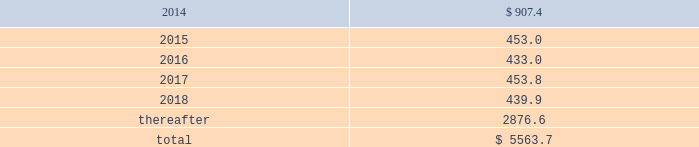Maturities of long-term debt in each of the next five years and beyond are as follows: .
On 4 february 2013 , we issued a $ 400.0 senior fixed-rate 2.75% ( 2.75 % ) note that matures on 3 february 2023 .
Additionally , on 7 august 2013 , we issued a 2.0% ( 2.0 % ) eurobond for 20ac300 million ( $ 397 ) that matures on 7 august 2020 .
Various debt agreements to which we are a party also include financial covenants and other restrictions , including restrictions pertaining to the ability to create property liens and enter into certain sale and leaseback transactions .
As of 30 september 2013 , we are in compliance with all the financial and other covenants under our debt agreements .
As of 30 september 2013 , we have classified commercial paper of $ 400.0 maturing in 2014 as long-term debt because we have the ability and intent to refinance the debt under our $ 2500.0 committed credit facility maturing in 2018 .
Our current intent is to refinance this debt via the u.s .
Public or private placement markets .
On 30 april 2013 , we entered into a five-year $ 2500.0 revolving credit agreement with a syndicate of banks ( the 201c2013 credit agreement 201d ) , under which senior unsecured debt is available to us and certain of our subsidiaries .
The 2013 credit agreement provides us with a source of liquidity and supports our commercial paper program .
This agreement increases the previously existing facility by $ 330.0 , extends the maturity date to 30 april 2018 , and modifies the financial covenant to a maximum ratio of total debt to total capitalization ( total debt plus total equity plus redeemable noncontrolling interest ) no greater than 70% ( 70 % ) .
No borrowings were outstanding under the 2013 credit agreement as of 30 september 2013 .
The 2013 credit agreement terminates and replaces our previous $ 2170.0 revolving credit agreement dated 8 july 2010 , as subsequently amended , which was to mature 30 june 2015 and had a financial covenant of long-term debt divided by the sum of long-term debt plus equity of no greater than 60% ( 60 % ) .
No borrowings were outstanding under the previous agreement at the time of its termination and no early termination penalties were incurred .
Effective 11 june 2012 , we entered into an offshore chinese renminbi ( rmb ) syndicated credit facility of rmb1000.0 million ( $ 163.5 ) , maturing in june 2015 .
There are rmb250.0 million ( $ 40.9 ) in outstanding borrowings under this commitment at 30 september 2013 .
Additional commitments totaling $ 383.0 are maintained by our foreign subsidiaries , of which $ 309.0 was borrowed and outstanding at 30 september 2013. .
What is going to be the matured value of the $ 400.0 issued in 2013? 
Rationale: it is the original $ 400 calculated in the compound interest formula , in which 2.75% is going to be the interest and 10 is going to be the period ( 2023-2013 ) .
Computations: (400.0 * ((1 + 2.75%) ** 10))
Answer: 524.66041. 